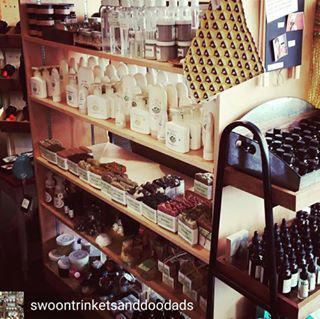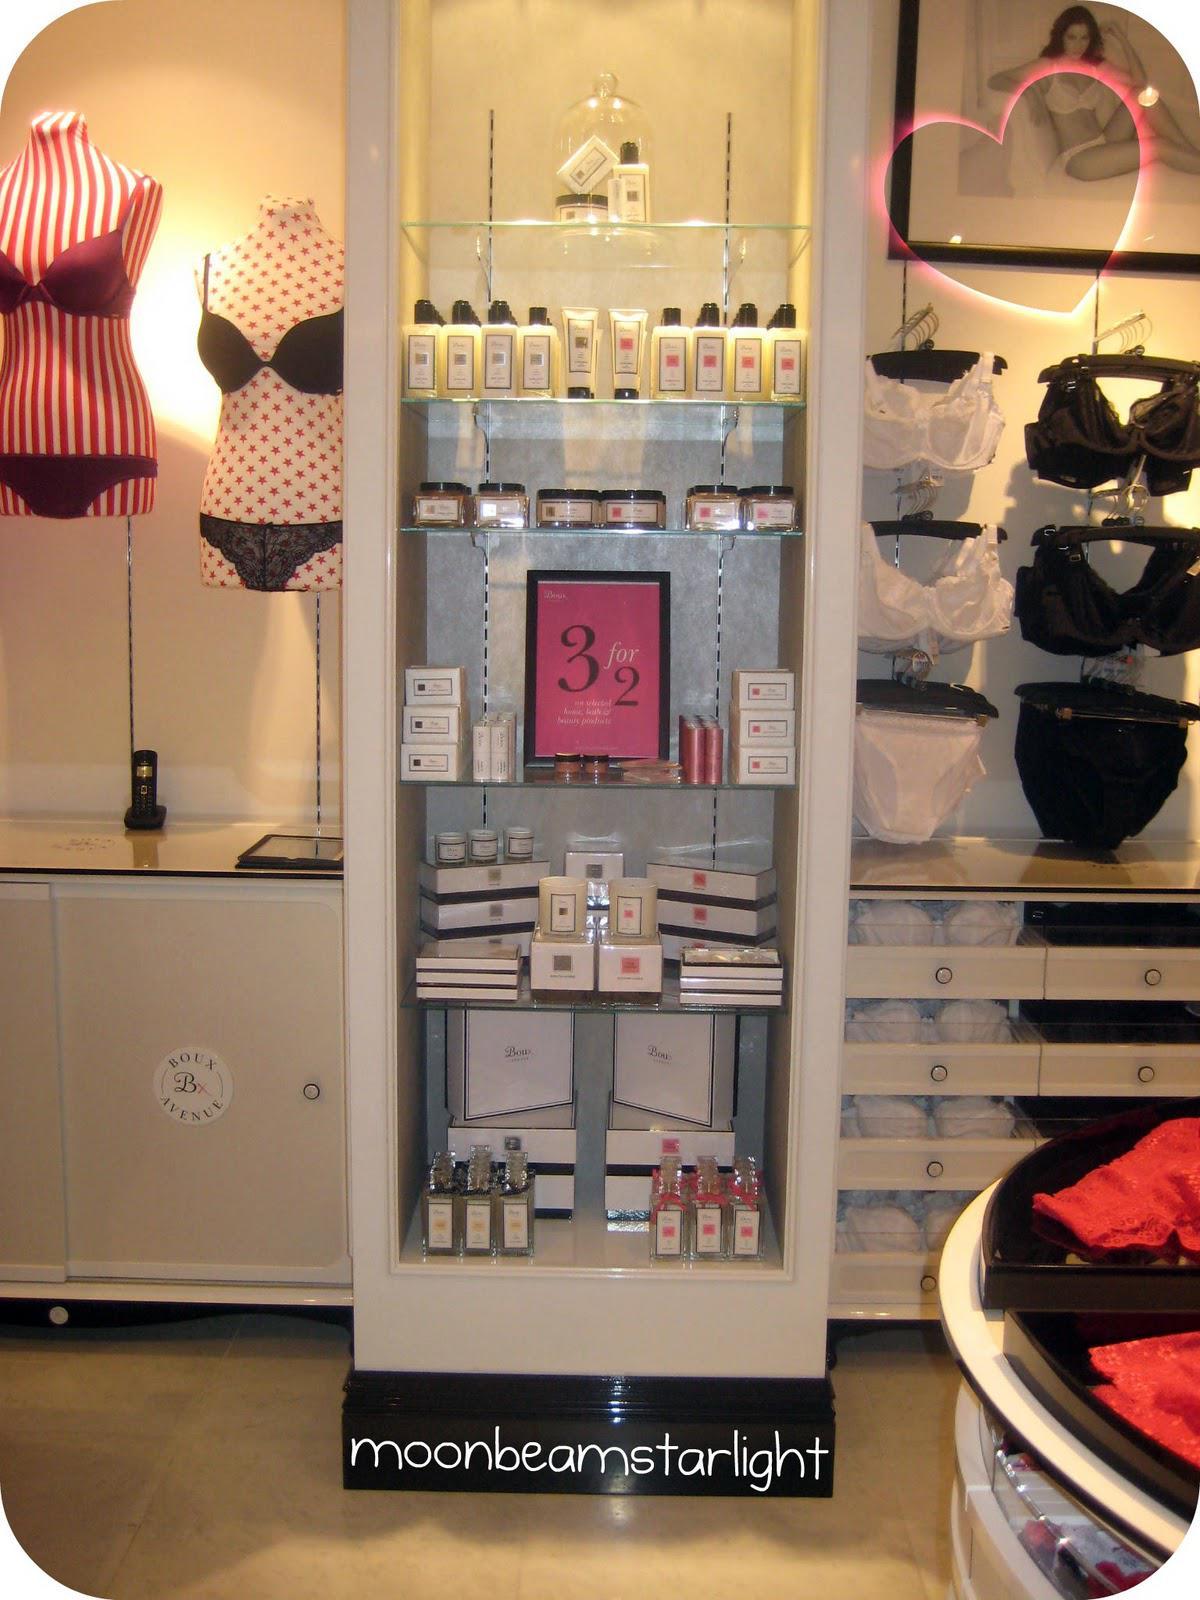The first image is the image on the left, the second image is the image on the right. Analyze the images presented: Is the assertion "Many different kinds of tanning lotion hang behind a booth that reads Tanning Shop." valid? Answer yes or no. No. The first image is the image on the left, the second image is the image on the right. Given the left and right images, does the statement "Below the salable items, you'll notice the words, """"Tanning Shop""""" hold true? Answer yes or no. No. 